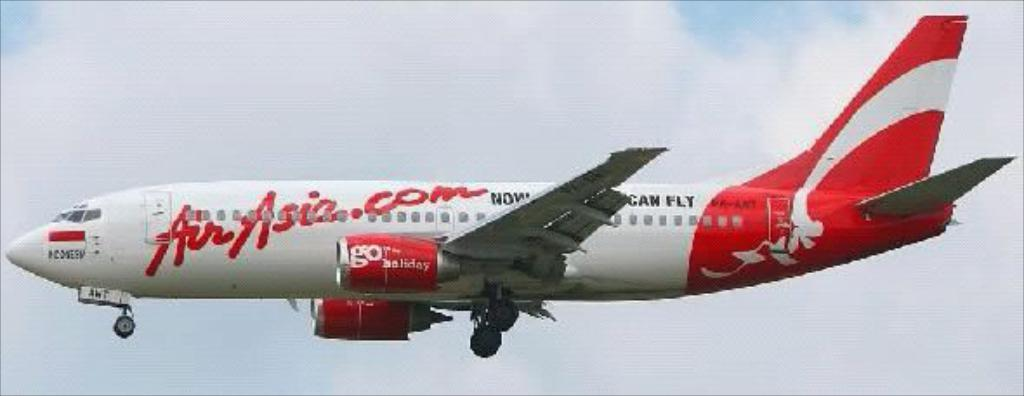What is the main subject of the image? There is an aeroplane in the image. What is the aeroplane doing in the image? The aeroplane is flying in the air. What can be seen in the background of the image? There are clouds in the sky in the background of the image. What type of farm can be seen in the image? There is no farm present in the image; it features an aeroplane flying in the air. How much tax is being paid for the aeroplane in the image? There is no information about taxes in the image, as it only shows an aeroplane flying in the air. 